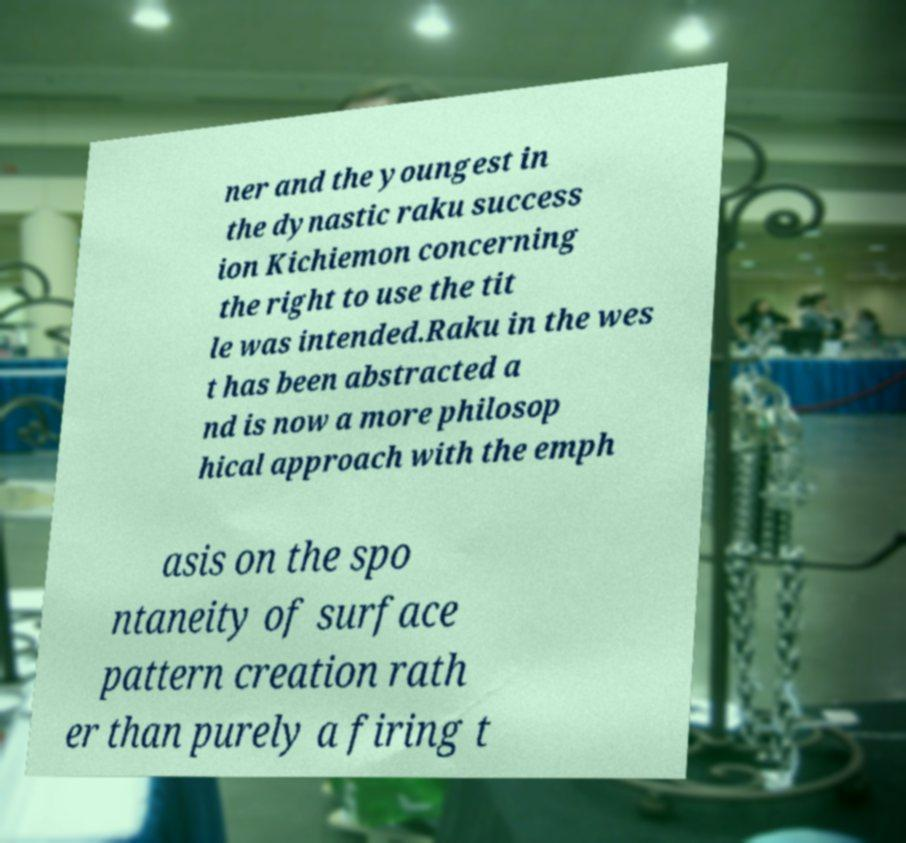Please read and relay the text visible in this image. What does it say? ner and the youngest in the dynastic raku success ion Kichiemon concerning the right to use the tit le was intended.Raku in the wes t has been abstracted a nd is now a more philosop hical approach with the emph asis on the spo ntaneity of surface pattern creation rath er than purely a firing t 